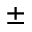Convert formula to latex. <formula><loc_0><loc_0><loc_500><loc_500>\pm</formula> 